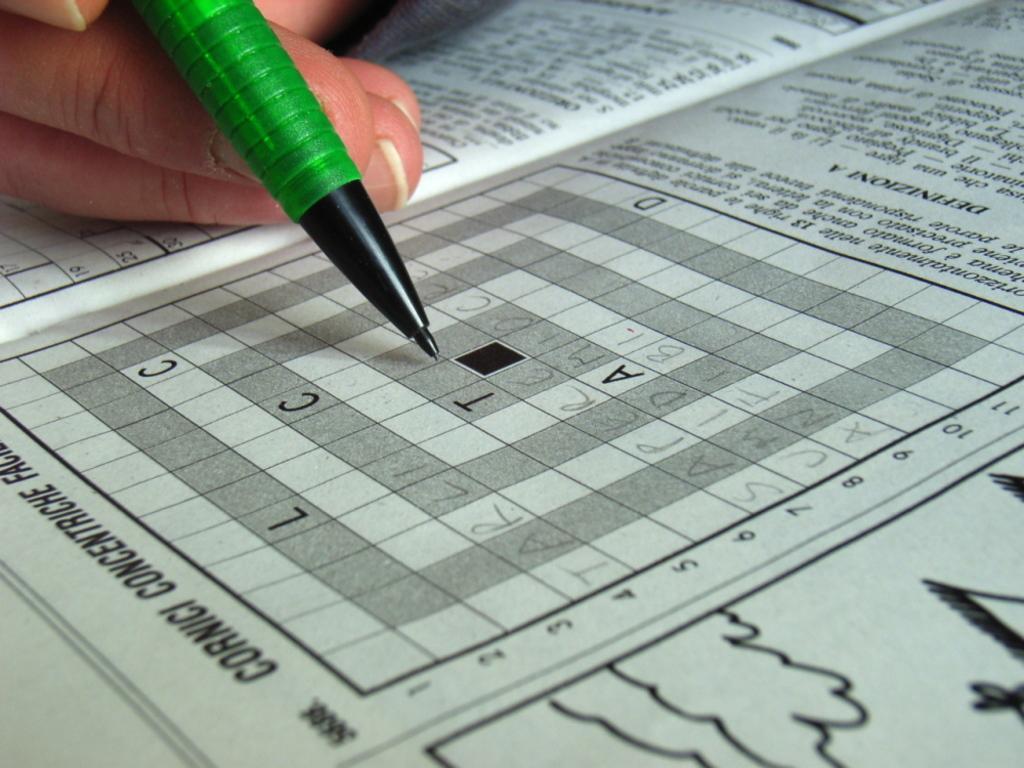How would you summarize this image in a sentence or two? This image consists of a person holding a pencil and doing a puzzle in the newspaper. At the bottom, there is a newspaper on the table. 